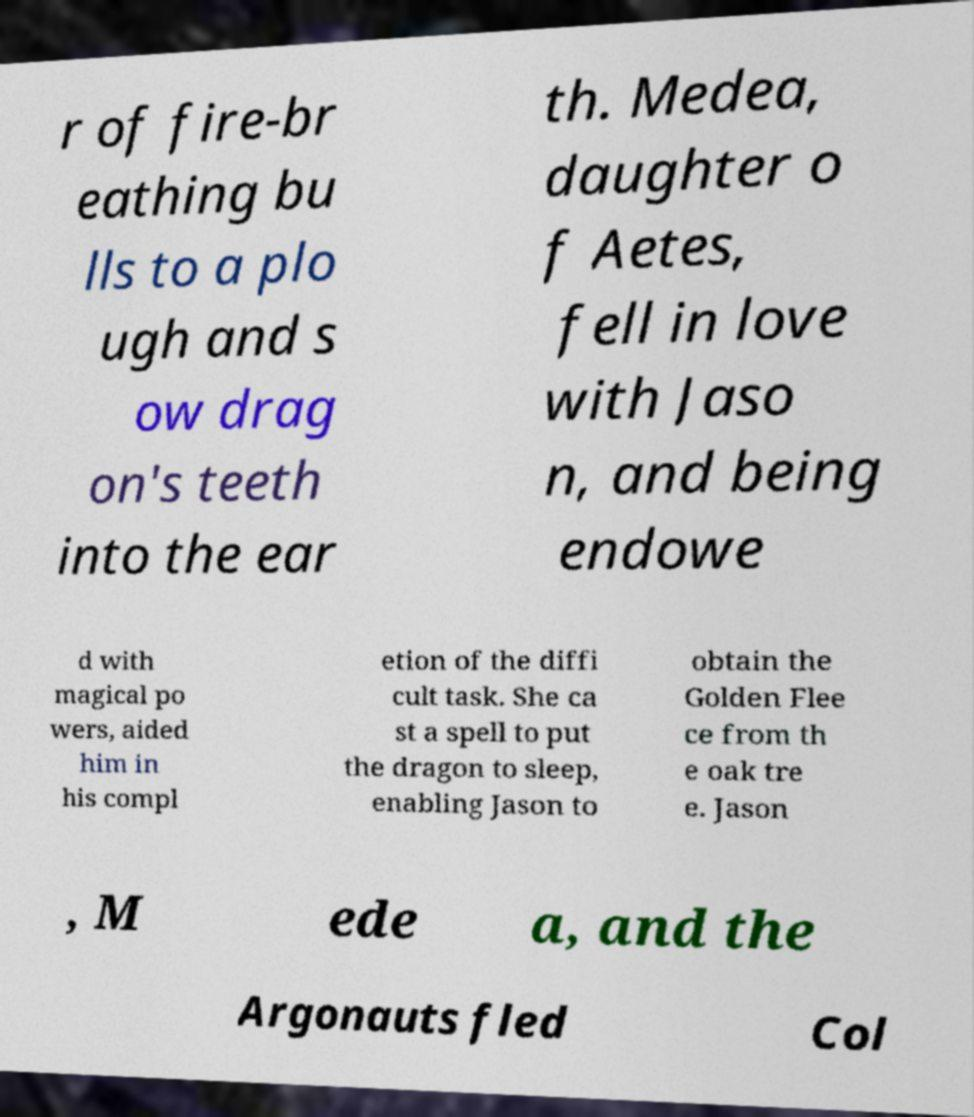What messages or text are displayed in this image? I need them in a readable, typed format. r of fire-br eathing bu lls to a plo ugh and s ow drag on's teeth into the ear th. Medea, daughter o f Aetes, fell in love with Jaso n, and being endowe d with magical po wers, aided him in his compl etion of the diffi cult task. She ca st a spell to put the dragon to sleep, enabling Jason to obtain the Golden Flee ce from th e oak tre e. Jason , M ede a, and the Argonauts fled Col 